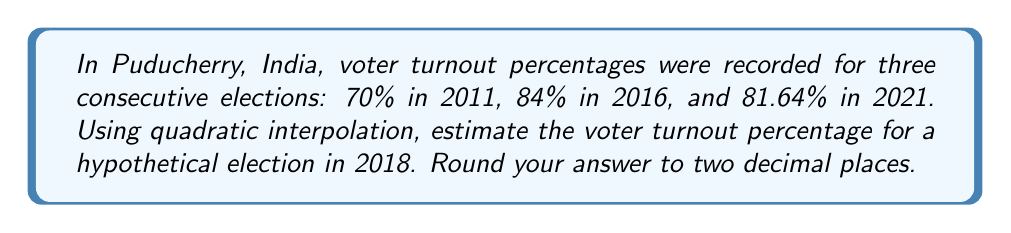Can you answer this question? To solve this problem, we'll use quadratic interpolation. Let's follow these steps:

1) Assign x-values to each year, with 2011 as x = 0:
   2011 (x = 0): 70%
   2016 (x = 5): 84%
   2021 (x = 10): 81.64%

2) We want to estimate for 2018, which would be x = 7.

3) The quadratic interpolation formula is:
   $$f(x) = f(x_0) + \frac{f[x_1,x_0]}{1!}(x-x_0) + \frac{f[x_2,x_1,x_0]}{2!}(x-x_0)(x-x_1)$$

   Where $f[x_1,x_0]$ is the first divided difference and $f[x_2,x_1,x_0]$ is the second divided difference.

4) Calculate the first divided differences:
   $$f[x_1,x_0] = \frac{f(x_1) - f(x_0)}{x_1 - x_0} = \frac{84 - 70}{5 - 0} = 2.8$$
   $$f[x_2,x_1] = \frac{f(x_2) - f(x_1)}{x_2 - x_1} = \frac{81.64 - 84}{10 - 5} = -0.472$$

5) Calculate the second divided difference:
   $$f[x_2,x_1,x_0] = \frac{f[x_2,x_1] - f[x_1,x_0]}{x_2 - x_0} = \frac{-0.472 - 2.8}{10 - 0} = -0.3272$$

6) Now, let's substitute these values into the quadratic interpolation formula:
   $$f(7) = 70 + 2.8(7-0) + \frac{-0.3272}{2}(7-0)(7-5)$$

7) Simplify:
   $$f(7) = 70 + 19.6 - 1.3088 = 88.2912$$

8) Rounding to two decimal places:
   $$f(7) \approx 88.29$$

Therefore, the estimated voter turnout for 2018 is 88.29%.
Answer: 88.29% 